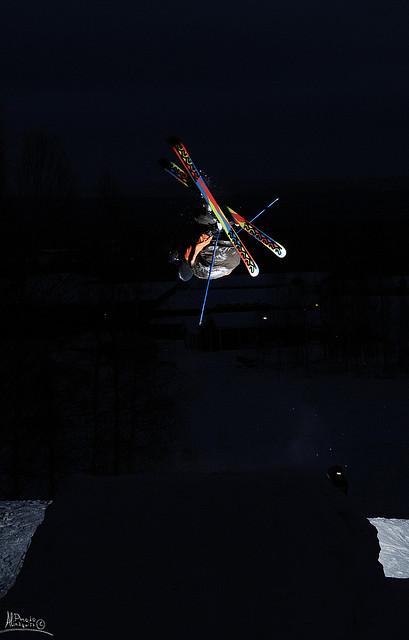Is this during the day or night?
Keep it brief. Night. Is there snow on the ground?
Answer briefly. Yes. What is the bright object?
Answer briefly. Skier. 